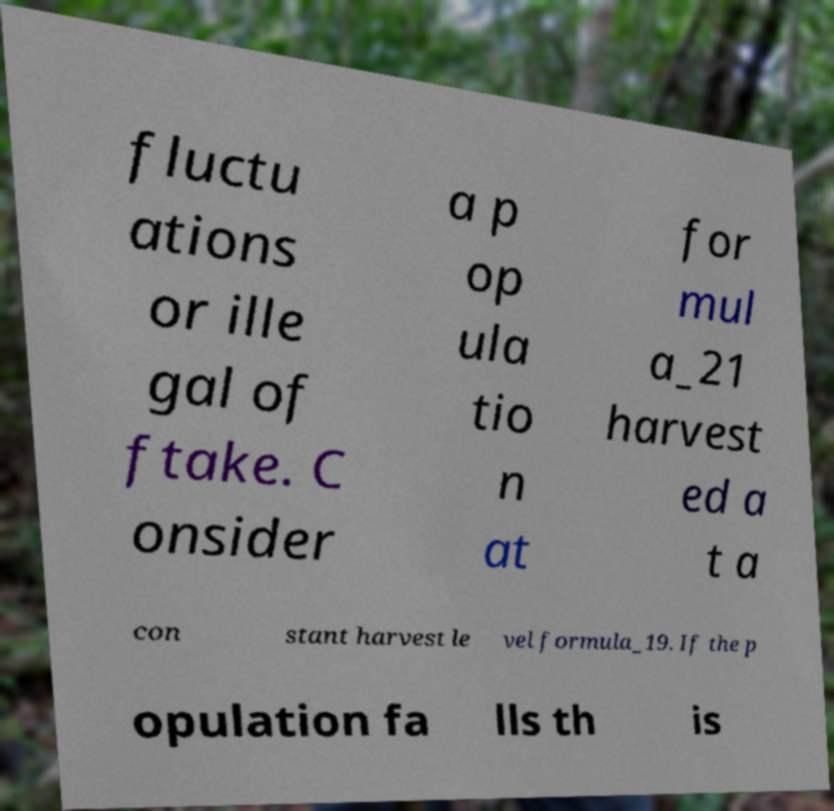Could you extract and type out the text from this image? fluctu ations or ille gal of ftake. C onsider a p op ula tio n at for mul a_21 harvest ed a t a con stant harvest le vel formula_19. If the p opulation fa lls th is 